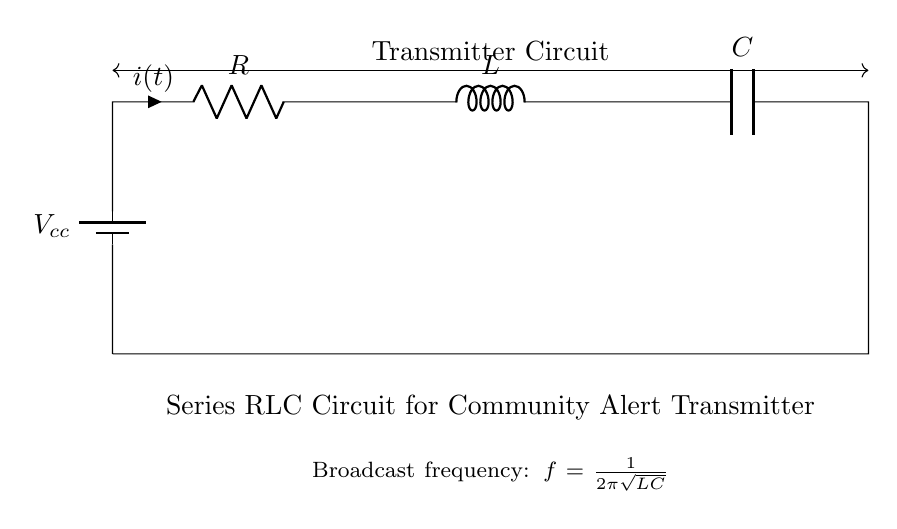What is the power supply voltage in this circuit? The power supply voltage is indicated by the battery symbol labeled as Vcc at the beginning of the circuit. It represents the voltage provided to the entire circuit.
Answer: Vcc What is the component after the resistor? The component immediately following the resistor R in the circuit diagram is marked as L, which represents an inductor.
Answer: L What are the three components in this circuit? The three components in this circuit are a resistor, an inductor, and a capacitor, collectively known as RLC components, which are connected in series.
Answer: Resistor, Inductor, Capacitor How is the circuit connected to the antenna? The circuit is connected to the antenna at the end of the capacitor, where it connects back to the starting point of the circuit, forming a loop.
Answer: In series What is the formula for the broadcast frequency in this circuit? The formula is given below the circuit and states that the broadcast frequency is calculated as f = 1/(2π√(LC)), indicating the relationship between frequency and the values of L and C.
Answer: f = 1/(2π√(LC)) What does the 'i(t)' represent in this diagram? The 'i(t)' symbol next to the resistor represents the instantaneous current flowing through the circuit as a function of time.
Answer: Instantaneous current How does the inductor affect the overall circuit behavior? The inductor in this series RLC circuit introduces inductive reactance, which affects the circuit's impedance, impacts phase relationships, and influences resonance depending on the interaction with the resistor and capacitor.
Answer: Inductive reactance 